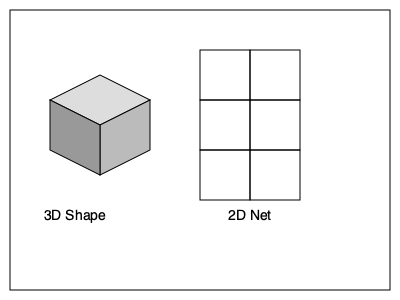As an English teacher in Kosovo, you're preparing a lesson on spatial reasoning. Which 2D net representation correctly unfolds to form the 3D cube shown in the image? To determine the correct 2D net representation for the given 3D cube, we need to follow these steps:

1. Identify the cube's faces: The cube has 6 square faces.

2. Analyze the 2D net: The net shown has 6 square faces arranged in a cross-like pattern.

3. Mental unfolding:
   a) The top face of the cube corresponds to the top square of the net.
   b) The front face unfolds downward, becoming the second square from the top.
   c) The right face unfolds to the right, becoming the right-middle square.
   d) The left face unfolds to the left, becoming the left-middle square.
   e) The bottom face of the cube becomes the bottom square of the net.
   f) The back face unfolds upward, becoming the third square from the top.

4. Verify: When folded along the edges, this net will form a cube identical to the one shown in the 3D representation.

5. Compare: The 2D net shown in the image matches this unfolding pattern, confirming it's the correct representation for the given 3D cube.
Answer: The 2D net shown is correct. 